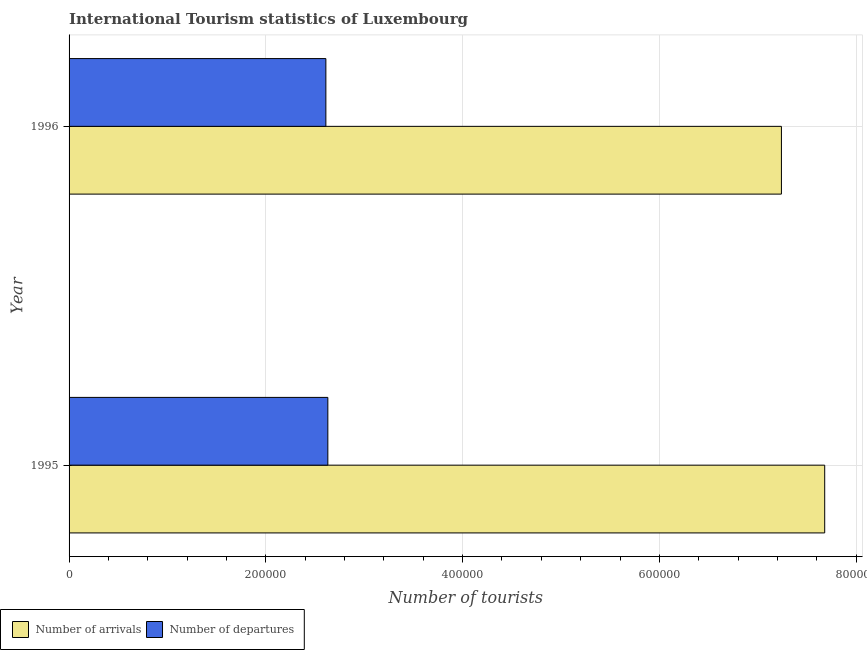How many different coloured bars are there?
Offer a very short reply. 2. How many groups of bars are there?
Offer a terse response. 2. Are the number of bars per tick equal to the number of legend labels?
Keep it short and to the point. Yes. How many bars are there on the 2nd tick from the bottom?
Ensure brevity in your answer.  2. What is the label of the 2nd group of bars from the top?
Ensure brevity in your answer.  1995. In how many cases, is the number of bars for a given year not equal to the number of legend labels?
Offer a terse response. 0. What is the number of tourist departures in 1995?
Ensure brevity in your answer.  2.63e+05. Across all years, what is the maximum number of tourist departures?
Keep it short and to the point. 2.63e+05. Across all years, what is the minimum number of tourist arrivals?
Provide a succinct answer. 7.24e+05. In which year was the number of tourist departures minimum?
Provide a short and direct response. 1996. What is the total number of tourist departures in the graph?
Provide a succinct answer. 5.24e+05. What is the difference between the number of tourist arrivals in 1995 and the number of tourist departures in 1996?
Offer a very short reply. 5.07e+05. What is the average number of tourist arrivals per year?
Your answer should be very brief. 7.46e+05. In the year 1995, what is the difference between the number of tourist arrivals and number of tourist departures?
Keep it short and to the point. 5.05e+05. In how many years, is the number of tourist departures greater than 480000 ?
Your response must be concise. 0. Is the difference between the number of tourist arrivals in 1995 and 1996 greater than the difference between the number of tourist departures in 1995 and 1996?
Your response must be concise. Yes. In how many years, is the number of tourist arrivals greater than the average number of tourist arrivals taken over all years?
Make the answer very short. 1. What does the 1st bar from the top in 1996 represents?
Your answer should be compact. Number of departures. What does the 2nd bar from the bottom in 1995 represents?
Your answer should be very brief. Number of departures. How many bars are there?
Provide a succinct answer. 4. How many years are there in the graph?
Keep it short and to the point. 2. Does the graph contain any zero values?
Give a very brief answer. No. Does the graph contain grids?
Give a very brief answer. Yes. Where does the legend appear in the graph?
Make the answer very short. Bottom left. How many legend labels are there?
Your response must be concise. 2. What is the title of the graph?
Ensure brevity in your answer.  International Tourism statistics of Luxembourg. Does "Public funds" appear as one of the legend labels in the graph?
Give a very brief answer. No. What is the label or title of the X-axis?
Offer a very short reply. Number of tourists. What is the Number of tourists of Number of arrivals in 1995?
Give a very brief answer. 7.68e+05. What is the Number of tourists in Number of departures in 1995?
Ensure brevity in your answer.  2.63e+05. What is the Number of tourists of Number of arrivals in 1996?
Provide a short and direct response. 7.24e+05. What is the Number of tourists of Number of departures in 1996?
Your response must be concise. 2.61e+05. Across all years, what is the maximum Number of tourists of Number of arrivals?
Provide a short and direct response. 7.68e+05. Across all years, what is the maximum Number of tourists in Number of departures?
Offer a terse response. 2.63e+05. Across all years, what is the minimum Number of tourists in Number of arrivals?
Offer a terse response. 7.24e+05. Across all years, what is the minimum Number of tourists in Number of departures?
Provide a succinct answer. 2.61e+05. What is the total Number of tourists of Number of arrivals in the graph?
Provide a short and direct response. 1.49e+06. What is the total Number of tourists in Number of departures in the graph?
Your response must be concise. 5.24e+05. What is the difference between the Number of tourists of Number of arrivals in 1995 and that in 1996?
Ensure brevity in your answer.  4.40e+04. What is the difference between the Number of tourists in Number of departures in 1995 and that in 1996?
Make the answer very short. 2000. What is the difference between the Number of tourists in Number of arrivals in 1995 and the Number of tourists in Number of departures in 1996?
Your answer should be very brief. 5.07e+05. What is the average Number of tourists of Number of arrivals per year?
Ensure brevity in your answer.  7.46e+05. What is the average Number of tourists in Number of departures per year?
Provide a short and direct response. 2.62e+05. In the year 1995, what is the difference between the Number of tourists in Number of arrivals and Number of tourists in Number of departures?
Provide a short and direct response. 5.05e+05. In the year 1996, what is the difference between the Number of tourists in Number of arrivals and Number of tourists in Number of departures?
Keep it short and to the point. 4.63e+05. What is the ratio of the Number of tourists of Number of arrivals in 1995 to that in 1996?
Offer a terse response. 1.06. What is the ratio of the Number of tourists in Number of departures in 1995 to that in 1996?
Provide a short and direct response. 1.01. What is the difference between the highest and the second highest Number of tourists in Number of arrivals?
Your answer should be very brief. 4.40e+04. What is the difference between the highest and the second highest Number of tourists in Number of departures?
Offer a very short reply. 2000. What is the difference between the highest and the lowest Number of tourists of Number of arrivals?
Provide a succinct answer. 4.40e+04. What is the difference between the highest and the lowest Number of tourists of Number of departures?
Provide a short and direct response. 2000. 